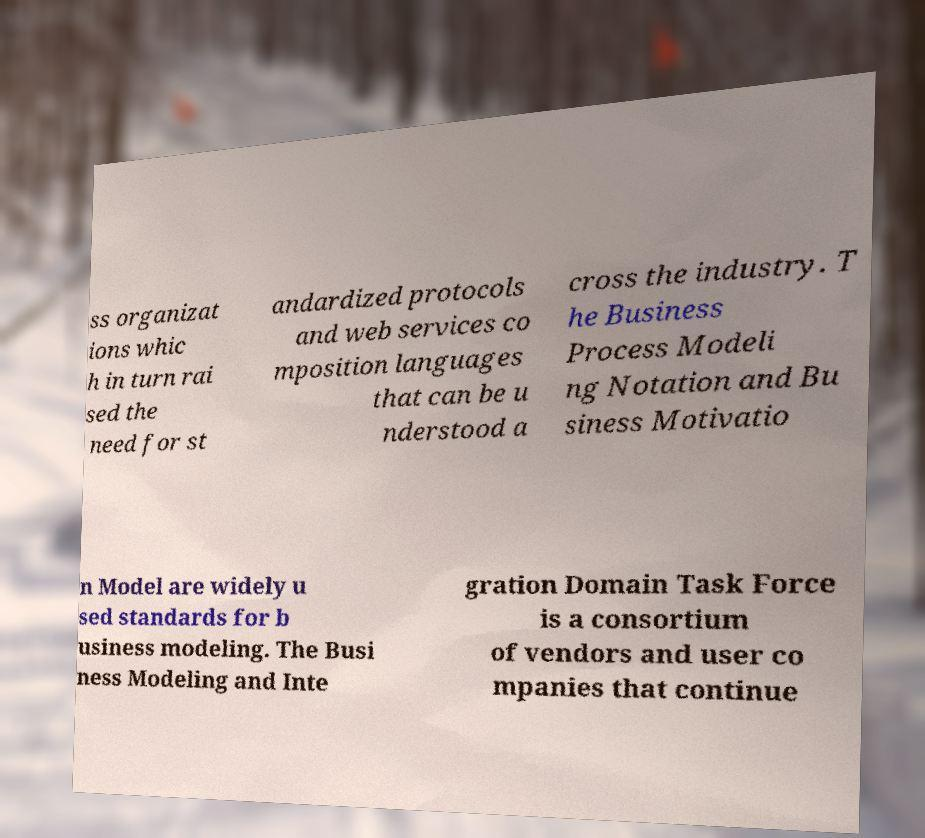Can you read and provide the text displayed in the image?This photo seems to have some interesting text. Can you extract and type it out for me? ss organizat ions whic h in turn rai sed the need for st andardized protocols and web services co mposition languages that can be u nderstood a cross the industry. T he Business Process Modeli ng Notation and Bu siness Motivatio n Model are widely u sed standards for b usiness modeling. The Busi ness Modeling and Inte gration Domain Task Force is a consortium of vendors and user co mpanies that continue 